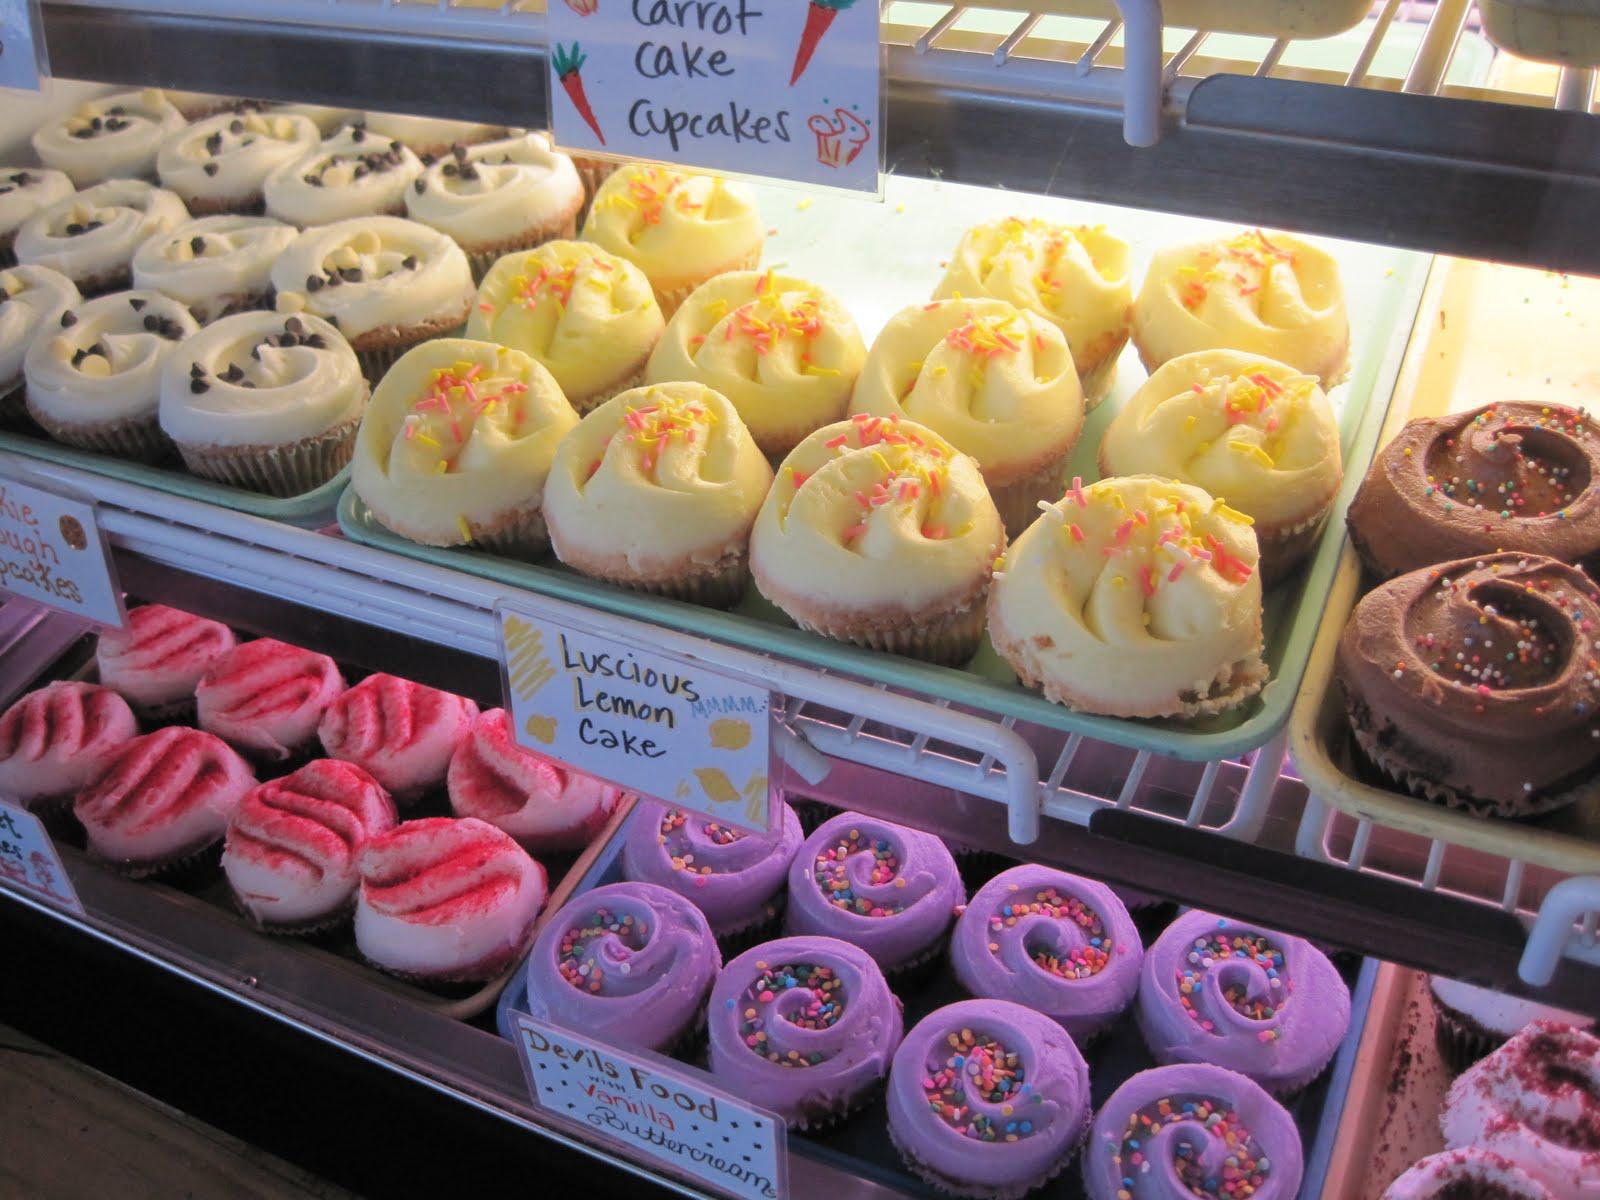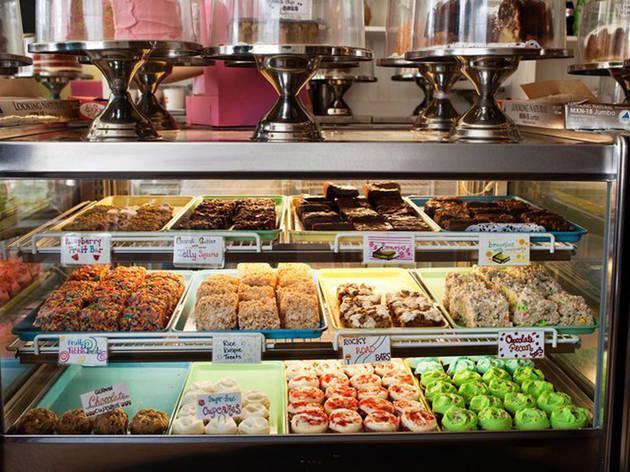The first image is the image on the left, the second image is the image on the right. Examine the images to the left and right. Is the description "There are lemon pastries on the middle shelf." accurate? Answer yes or no. Yes. The first image is the image on the left, the second image is the image on the right. Examine the images to the left and right. Is the description "One image shows a line of desserts displayed under glass on silver pedestals atop a counter, and the other image shows a glass display front that includes pink, yellow, white and brown frosted cupcakes." accurate? Answer yes or no. Yes. 